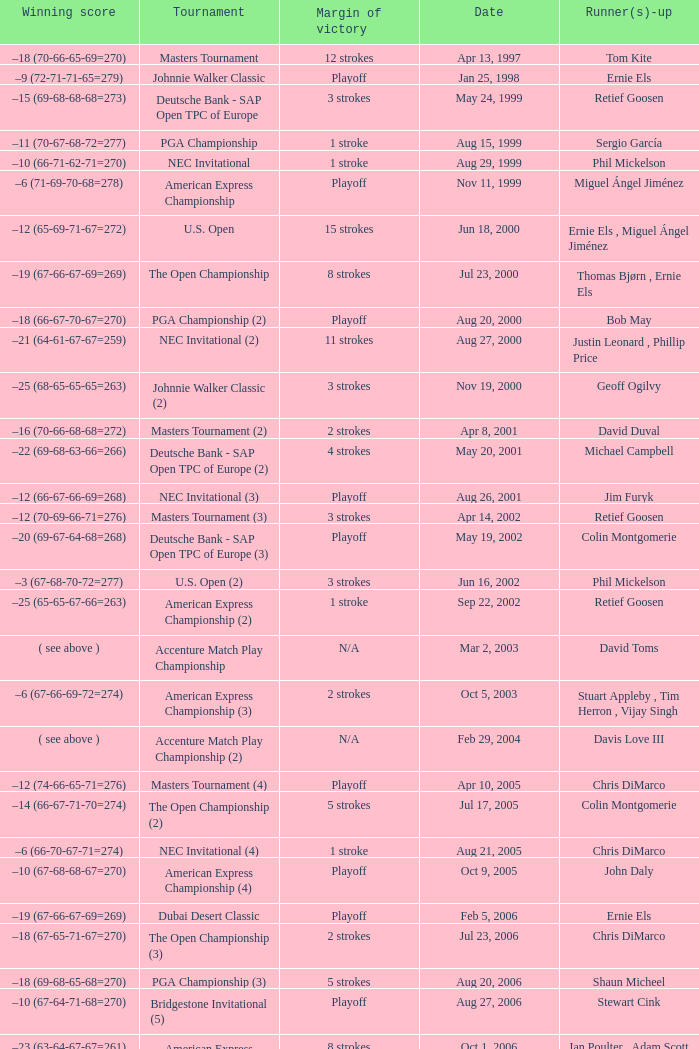Who has the Winning score of –10 (66-71-62-71=270) ? Phil Mickelson. Parse the full table. {'header': ['Winning score', 'Tournament', 'Margin of victory', 'Date', 'Runner(s)-up'], 'rows': [['–18 (70-66-65-69=270)', 'Masters Tournament', '12 strokes', 'Apr 13, 1997', 'Tom Kite'], ['–9 (72-71-71-65=279)', 'Johnnie Walker Classic', 'Playoff', 'Jan 25, 1998', 'Ernie Els'], ['–15 (69-68-68-68=273)', 'Deutsche Bank - SAP Open TPC of Europe', '3 strokes', 'May 24, 1999', 'Retief Goosen'], ['–11 (70-67-68-72=277)', 'PGA Championship', '1 stroke', 'Aug 15, 1999', 'Sergio García'], ['–10 (66-71-62-71=270)', 'NEC Invitational', '1 stroke', 'Aug 29, 1999', 'Phil Mickelson'], ['–6 (71-69-70-68=278)', 'American Express Championship', 'Playoff', 'Nov 11, 1999', 'Miguel Ángel Jiménez'], ['–12 (65-69-71-67=272)', 'U.S. Open', '15 strokes', 'Jun 18, 2000', 'Ernie Els , Miguel Ángel Jiménez'], ['–19 (67-66-67-69=269)', 'The Open Championship', '8 strokes', 'Jul 23, 2000', 'Thomas Bjørn , Ernie Els'], ['–18 (66-67-70-67=270)', 'PGA Championship (2)', 'Playoff', 'Aug 20, 2000', 'Bob May'], ['–21 (64-61-67-67=259)', 'NEC Invitational (2)', '11 strokes', 'Aug 27, 2000', 'Justin Leonard , Phillip Price'], ['–25 (68-65-65-65=263)', 'Johnnie Walker Classic (2)', '3 strokes', 'Nov 19, 2000', 'Geoff Ogilvy'], ['–16 (70-66-68-68=272)', 'Masters Tournament (2)', '2 strokes', 'Apr 8, 2001', 'David Duval'], ['–22 (69-68-63-66=266)', 'Deutsche Bank - SAP Open TPC of Europe (2)', '4 strokes', 'May 20, 2001', 'Michael Campbell'], ['–12 (66-67-66-69=268)', 'NEC Invitational (3)', 'Playoff', 'Aug 26, 2001', 'Jim Furyk'], ['–12 (70-69-66-71=276)', 'Masters Tournament (3)', '3 strokes', 'Apr 14, 2002', 'Retief Goosen'], ['–20 (69-67-64-68=268)', 'Deutsche Bank - SAP Open TPC of Europe (3)', 'Playoff', 'May 19, 2002', 'Colin Montgomerie'], ['–3 (67-68-70-72=277)', 'U.S. Open (2)', '3 strokes', 'Jun 16, 2002', 'Phil Mickelson'], ['–25 (65-65-67-66=263)', 'American Express Championship (2)', '1 stroke', 'Sep 22, 2002', 'Retief Goosen'], ['( see above )', 'Accenture Match Play Championship', 'N/A', 'Mar 2, 2003', 'David Toms'], ['–6 (67-66-69-72=274)', 'American Express Championship (3)', '2 strokes', 'Oct 5, 2003', 'Stuart Appleby , Tim Herron , Vijay Singh'], ['( see above )', 'Accenture Match Play Championship (2)', 'N/A', 'Feb 29, 2004', 'Davis Love III'], ['–12 (74-66-65-71=276)', 'Masters Tournament (4)', 'Playoff', 'Apr 10, 2005', 'Chris DiMarco'], ['–14 (66-67-71-70=274)', 'The Open Championship (2)', '5 strokes', 'Jul 17, 2005', 'Colin Montgomerie'], ['–6 (66-70-67-71=274)', 'NEC Invitational (4)', '1 stroke', 'Aug 21, 2005', 'Chris DiMarco'], ['–10 (67-68-68-67=270)', 'American Express Championship (4)', 'Playoff', 'Oct 9, 2005', 'John Daly'], ['–19 (67-66-67-69=269)', 'Dubai Desert Classic', 'Playoff', 'Feb 5, 2006', 'Ernie Els'], ['–18 (67-65-71-67=270)', 'The Open Championship (3)', '2 strokes', 'Jul 23, 2006', 'Chris DiMarco'], ['–18 (69-68-65-68=270)', 'PGA Championship (3)', '5 strokes', 'Aug 20, 2006', 'Shaun Micheel'], ['–10 (67-64-71-68=270)', 'Bridgestone Invitational (5)', 'Playoff', 'Aug 27, 2006', 'Stewart Cink'], ['–23 (63-64-67-67=261)', 'American Express Championship (5)', '8 strokes', 'Oct 1, 2006', 'Ian Poulter , Adam Scott'], ['–10 (71-66-68-73=278)', 'CA Championship (6)', '2 strokes', 'Mar 25, 2007', 'Brett Wetterich'], ['−8 (68-70-69-65=272)', 'Bridgestone Invitational (6)', '8 strokes', 'Aug 5, 2007', 'Justin Rose , Rory Sabbatini'], ['–8 (71-63-69-69=272)', 'PGA Championship (4)', '2 strokes', 'Aug 12, 2007', 'Woody Austin'], ['–14 (65-71-73-65=274)', 'Dubai Desert Classic (2)', '1 stroke', 'Feb 3, 2008', 'Martin Kaymer'], ['( see above )', 'Accenture Match Play Championship (3)', 'N/A', 'Feb 24, 2008', 'Stewart Cink'], ['–1 (72-68-70-73=283)', 'U.S. Open (3)', 'Playoff', 'Jun 16, 2008', 'Rocco Mediate'], ['−12 (68-70-65-65=268)', 'Bridgestone Invitational (7)', '4 strokes', 'Aug 9, 2009', 'Robert Allenby , Pádraig Harrington'], ['–14 (66-68-72-68=274)', 'JBWere Masters', '2 strokes', 'Nov 15, 2009', 'Greg Chalmers'], ['–19 (66-65-67-71=269)', 'Cadillac Championship (7)', '2 strokes', 'Mar 10, 2013', 'Steve Stricker'], ['−15 (66-61-68-70=265)', 'Bridgestone Invitational (8)', '7 strokes', 'Aug 4, 2013', 'Keegan Bradley , Henrik Stenson']]} 